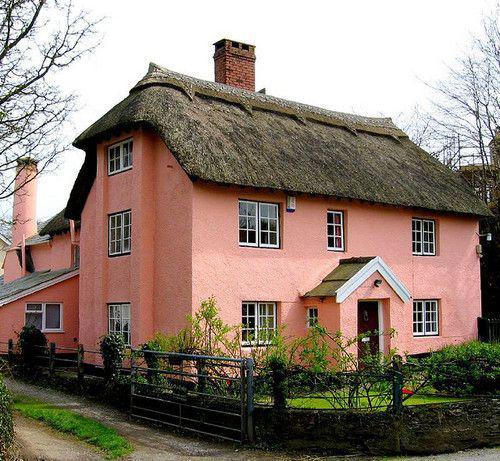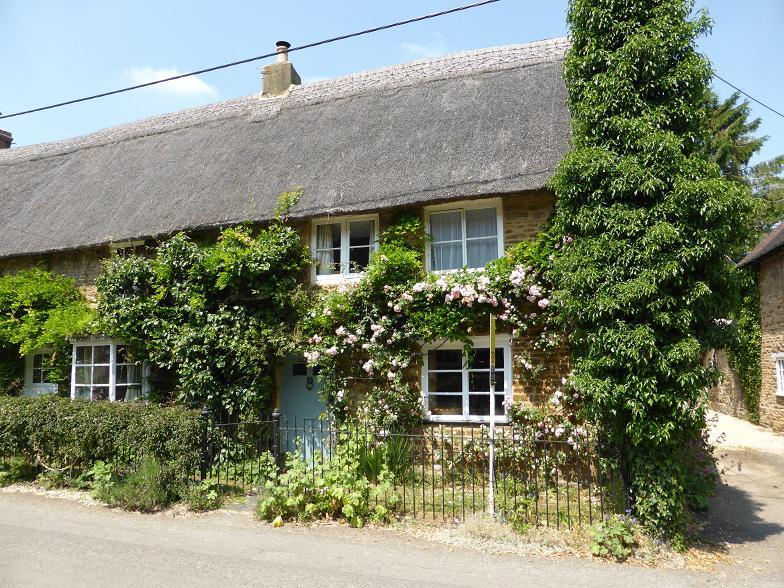The first image is the image on the left, the second image is the image on the right. Considering the images on both sides, is "Two buildings have second story windows." valid? Answer yes or no. Yes. The first image is the image on the left, the second image is the image on the right. Given the left and right images, does the statement "The building in the image on the right is fenced in." hold true? Answer yes or no. Yes. 